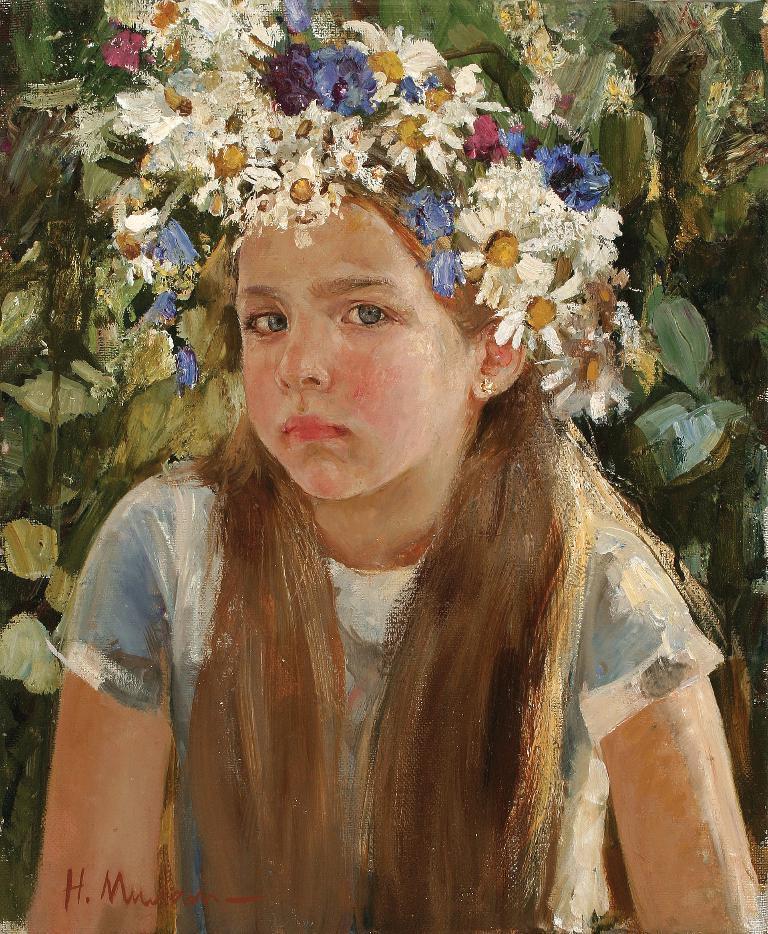In one or two sentences, can you explain what this image depicts? This is a painting. Here we can see a girl, flowers, plants. 